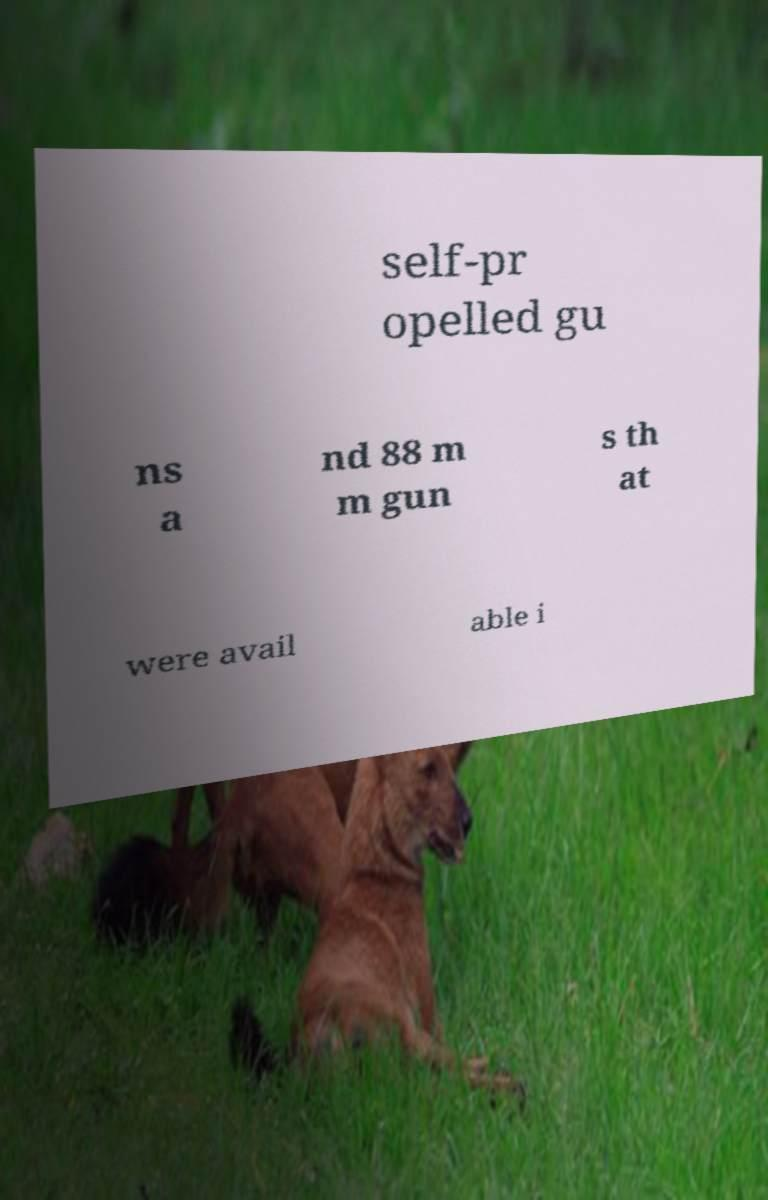For documentation purposes, I need the text within this image transcribed. Could you provide that? self-pr opelled gu ns a nd 88 m m gun s th at were avail able i 